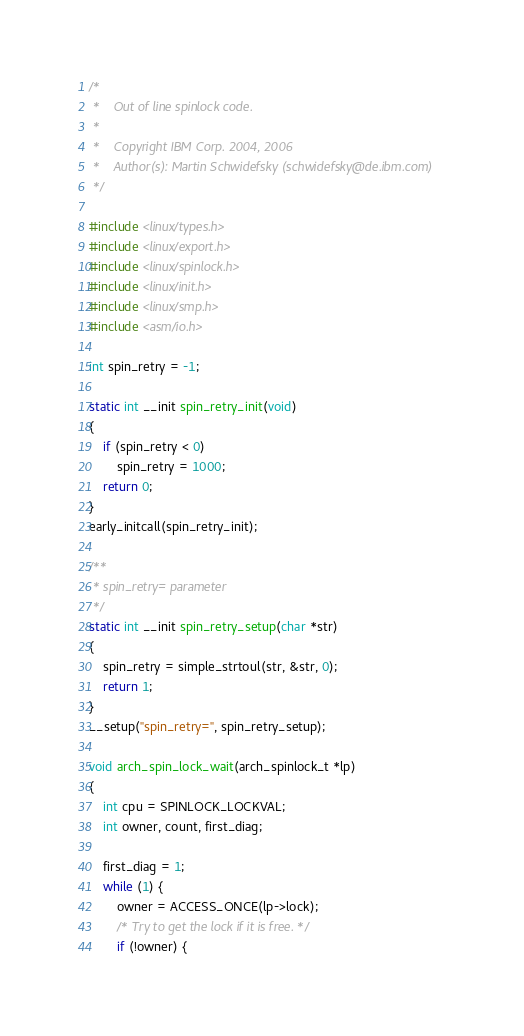Convert code to text. <code><loc_0><loc_0><loc_500><loc_500><_C_>/*
 *    Out of line spinlock code.
 *
 *    Copyright IBM Corp. 2004, 2006
 *    Author(s): Martin Schwidefsky (schwidefsky@de.ibm.com)
 */

#include <linux/types.h>
#include <linux/export.h>
#include <linux/spinlock.h>
#include <linux/init.h>
#include <linux/smp.h>
#include <asm/io.h>

int spin_retry = -1;

static int __init spin_retry_init(void)
{
	if (spin_retry < 0)
		spin_retry = 1000;
	return 0;
}
early_initcall(spin_retry_init);

/**
 * spin_retry= parameter
 */
static int __init spin_retry_setup(char *str)
{
	spin_retry = simple_strtoul(str, &str, 0);
	return 1;
}
__setup("spin_retry=", spin_retry_setup);

void arch_spin_lock_wait(arch_spinlock_t *lp)
{
	int cpu = SPINLOCK_LOCKVAL;
	int owner, count, first_diag;

	first_diag = 1;
	while (1) {
		owner = ACCESS_ONCE(lp->lock);
		/* Try to get the lock if it is free. */
		if (!owner) {</code> 